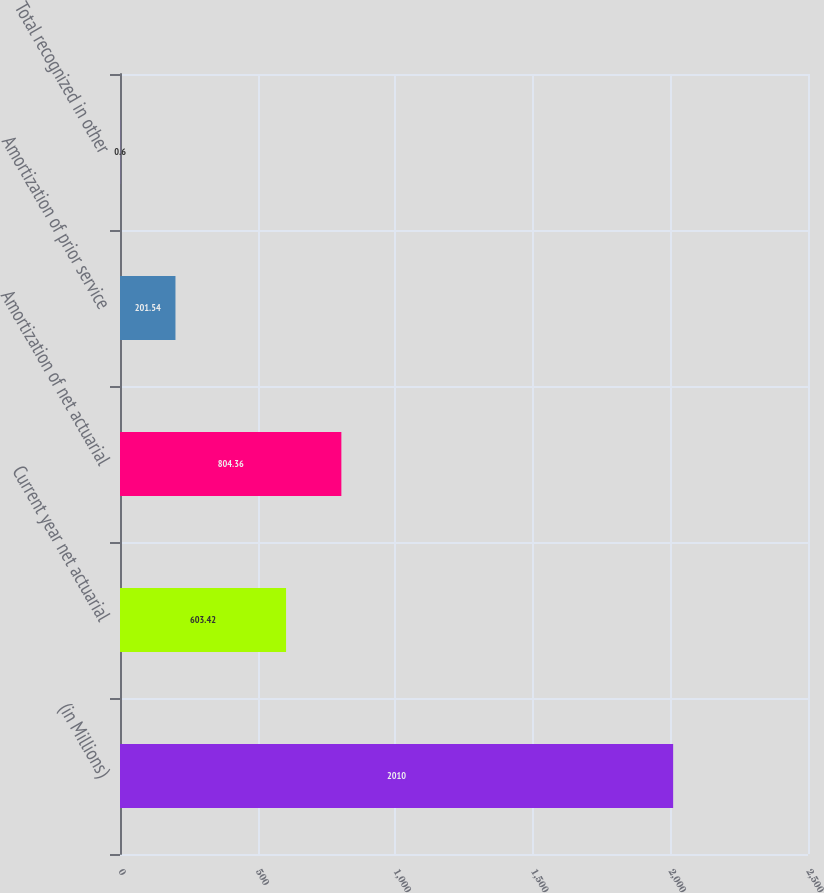<chart> <loc_0><loc_0><loc_500><loc_500><bar_chart><fcel>(in Millions)<fcel>Current year net actuarial<fcel>Amortization of net actuarial<fcel>Amortization of prior service<fcel>Total recognized in other<nl><fcel>2010<fcel>603.42<fcel>804.36<fcel>201.54<fcel>0.6<nl></chart> 